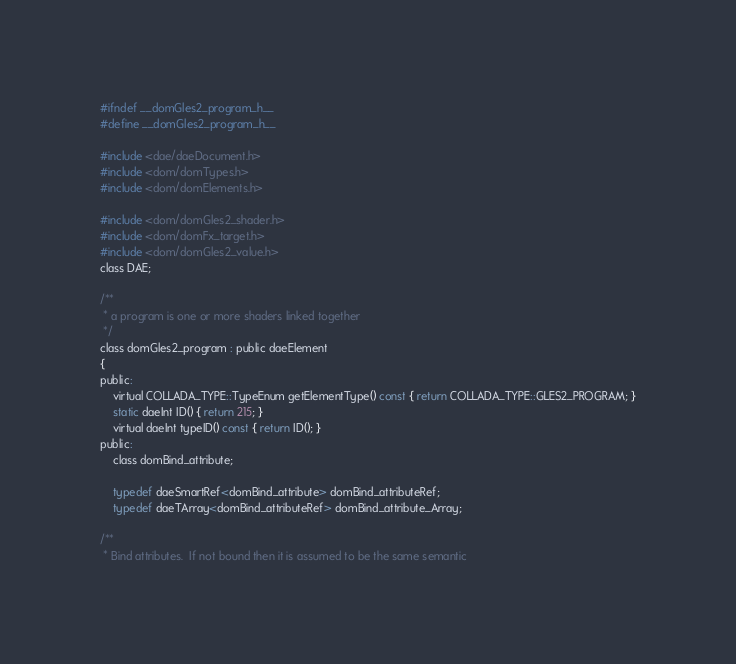<code> <loc_0><loc_0><loc_500><loc_500><_C_>#ifndef __domGles2_program_h__
#define __domGles2_program_h__

#include <dae/daeDocument.h>
#include <dom/domTypes.h>
#include <dom/domElements.h>

#include <dom/domGles2_shader.h>
#include <dom/domFx_target.h>
#include <dom/domGles2_value.h>
class DAE;

/**
 * a program is one or more shaders linked together
 */
class domGles2_program : public daeElement
{
public:
	virtual COLLADA_TYPE::TypeEnum getElementType() const { return COLLADA_TYPE::GLES2_PROGRAM; }
	static daeInt ID() { return 215; }
	virtual daeInt typeID() const { return ID(); }
public:
	class domBind_attribute;

	typedef daeSmartRef<domBind_attribute> domBind_attributeRef;
	typedef daeTArray<domBind_attributeRef> domBind_attribute_Array;

/**
 * Bind attributes.  If not bound then it is assumed to be the same semantic</code> 